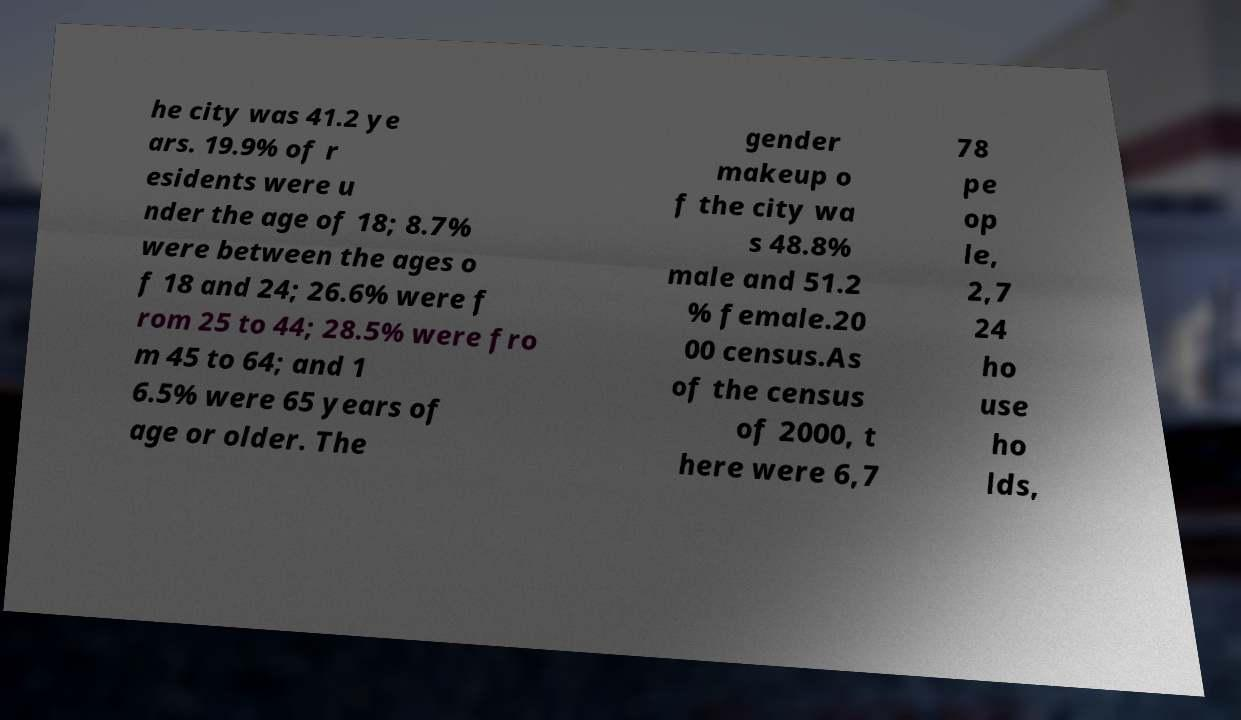Can you read and provide the text displayed in the image?This photo seems to have some interesting text. Can you extract and type it out for me? he city was 41.2 ye ars. 19.9% of r esidents were u nder the age of 18; 8.7% were between the ages o f 18 and 24; 26.6% were f rom 25 to 44; 28.5% were fro m 45 to 64; and 1 6.5% were 65 years of age or older. The gender makeup o f the city wa s 48.8% male and 51.2 % female.20 00 census.As of the census of 2000, t here were 6,7 78 pe op le, 2,7 24 ho use ho lds, 